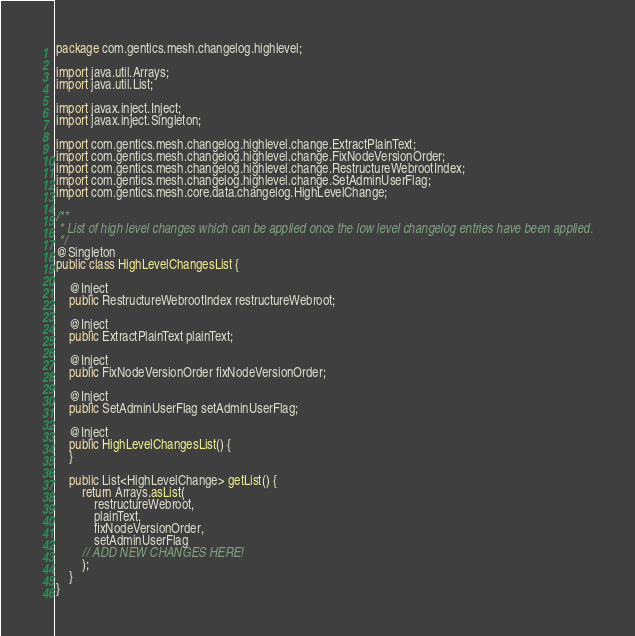Convert code to text. <code><loc_0><loc_0><loc_500><loc_500><_Java_>package com.gentics.mesh.changelog.highlevel;

import java.util.Arrays;
import java.util.List;

import javax.inject.Inject;
import javax.inject.Singleton;

import com.gentics.mesh.changelog.highlevel.change.ExtractPlainText;
import com.gentics.mesh.changelog.highlevel.change.FixNodeVersionOrder;
import com.gentics.mesh.changelog.highlevel.change.RestructureWebrootIndex;
import com.gentics.mesh.changelog.highlevel.change.SetAdminUserFlag;
import com.gentics.mesh.core.data.changelog.HighLevelChange;

/**
 * List of high level changes which can be applied once the low level changelog entries have been applied.
 */
@Singleton
public class HighLevelChangesList {

	@Inject
	public RestructureWebrootIndex restructureWebroot;

	@Inject
	public ExtractPlainText plainText;

	@Inject
	public FixNodeVersionOrder fixNodeVersionOrder;

	@Inject
	public SetAdminUserFlag setAdminUserFlag;

	@Inject
	public HighLevelChangesList() {
	}

	public List<HighLevelChange> getList() {
		return Arrays.asList(
			restructureWebroot,
			plainText,
			fixNodeVersionOrder,
			setAdminUserFlag
		// ADD NEW CHANGES HERE!
		);
	}
}
</code> 